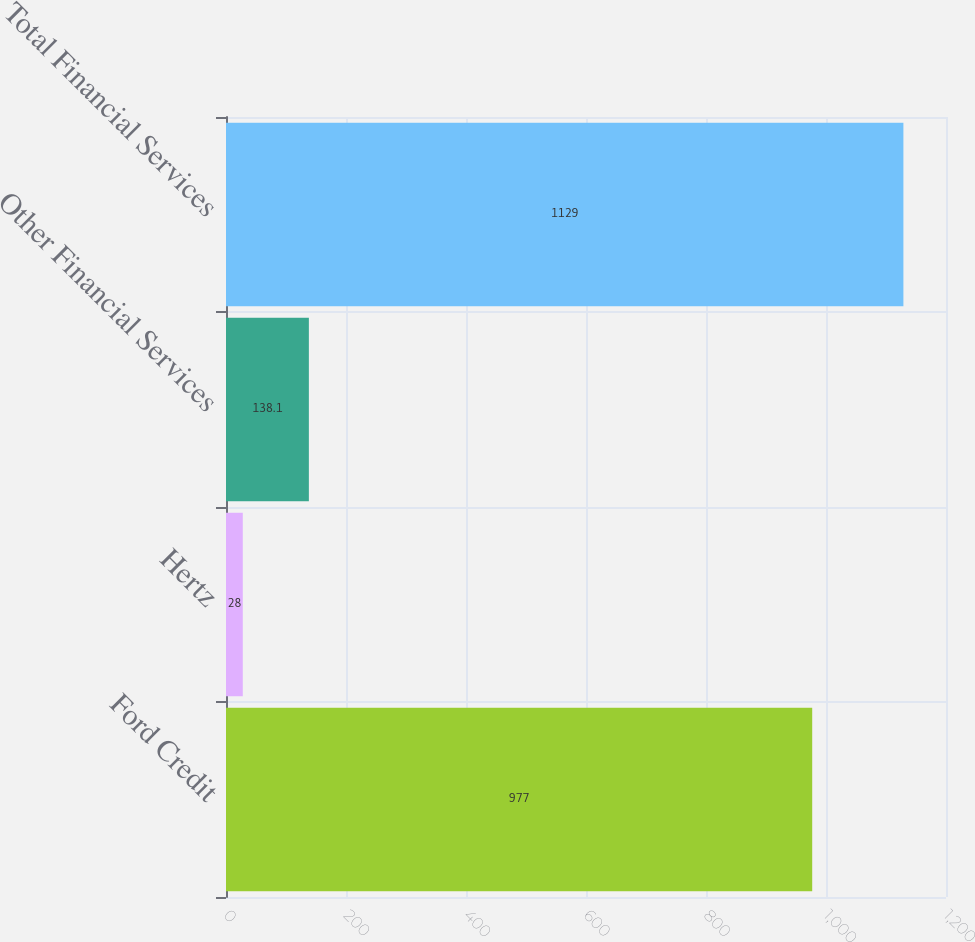<chart> <loc_0><loc_0><loc_500><loc_500><bar_chart><fcel>Ford Credit<fcel>Hertz<fcel>Other Financial Services<fcel>Total Financial Services<nl><fcel>977<fcel>28<fcel>138.1<fcel>1129<nl></chart> 